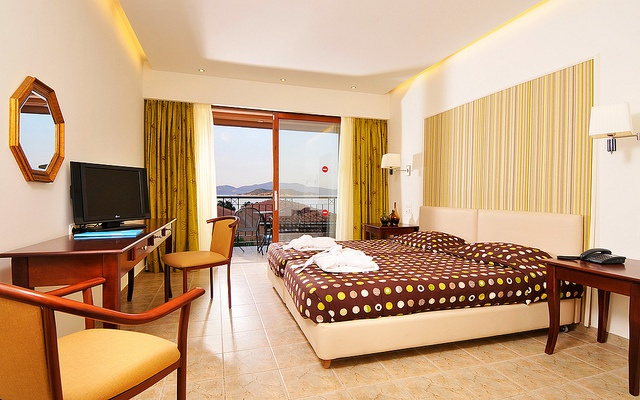Describe the objects in this image and their specific colors. I can see bed in beige, tan, maroon, and ivory tones, chair in beige, maroon, red, and tan tones, tv in beige, black, maroon, and olive tones, chair in beige, orange, maroon, and ivory tones, and chair in beige, black, maroon, brown, and red tones in this image. 